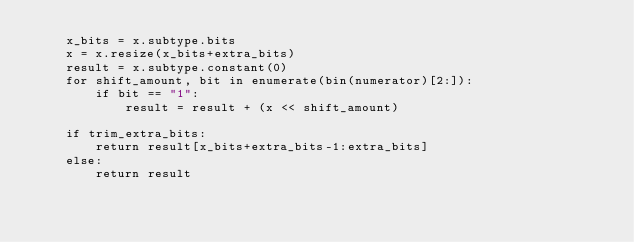<code> <loc_0><loc_0><loc_500><loc_500><_Python_>    x_bits = x.subtype.bits
    x = x.resize(x_bits+extra_bits)
    result = x.subtype.constant(0)
    for shift_amount, bit in enumerate(bin(numerator)[2:]):
        if bit == "1":
            result = result + (x << shift_amount)

    if trim_extra_bits:
        return result[x_bits+extra_bits-1:extra_bits]
    else:
        return result
</code> 